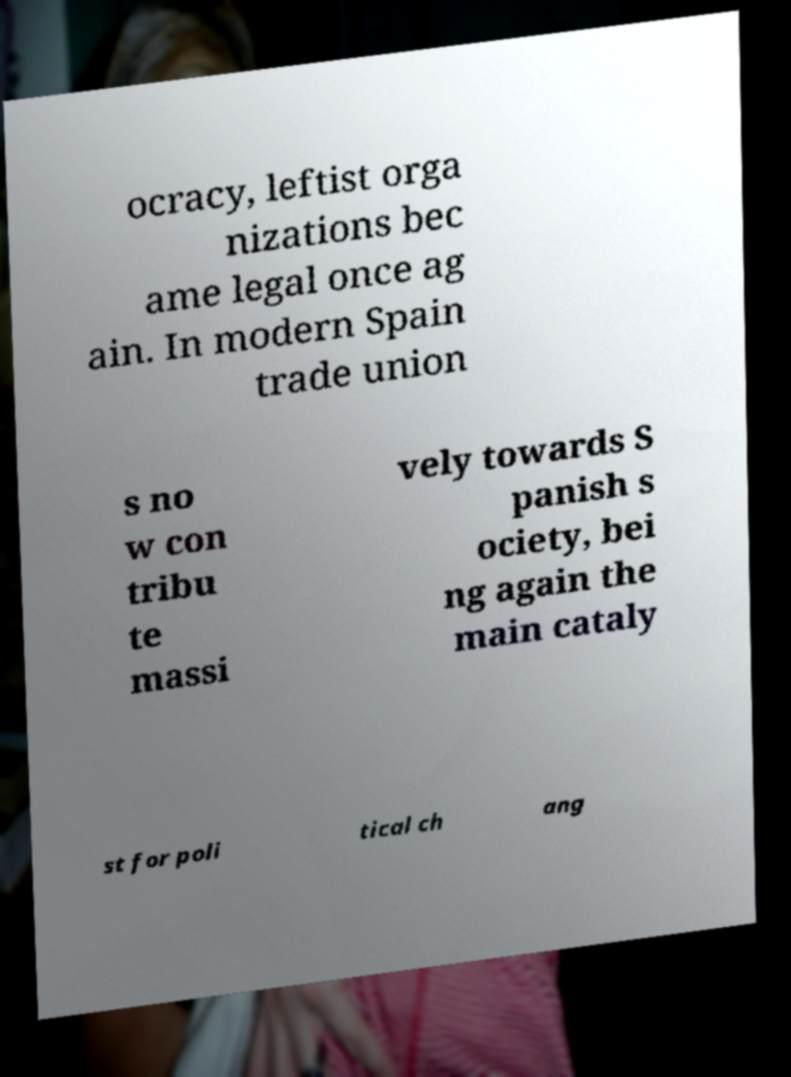Could you extract and type out the text from this image? ocracy, leftist orga nizations bec ame legal once ag ain. In modern Spain trade union s no w con tribu te massi vely towards S panish s ociety, bei ng again the main cataly st for poli tical ch ang 